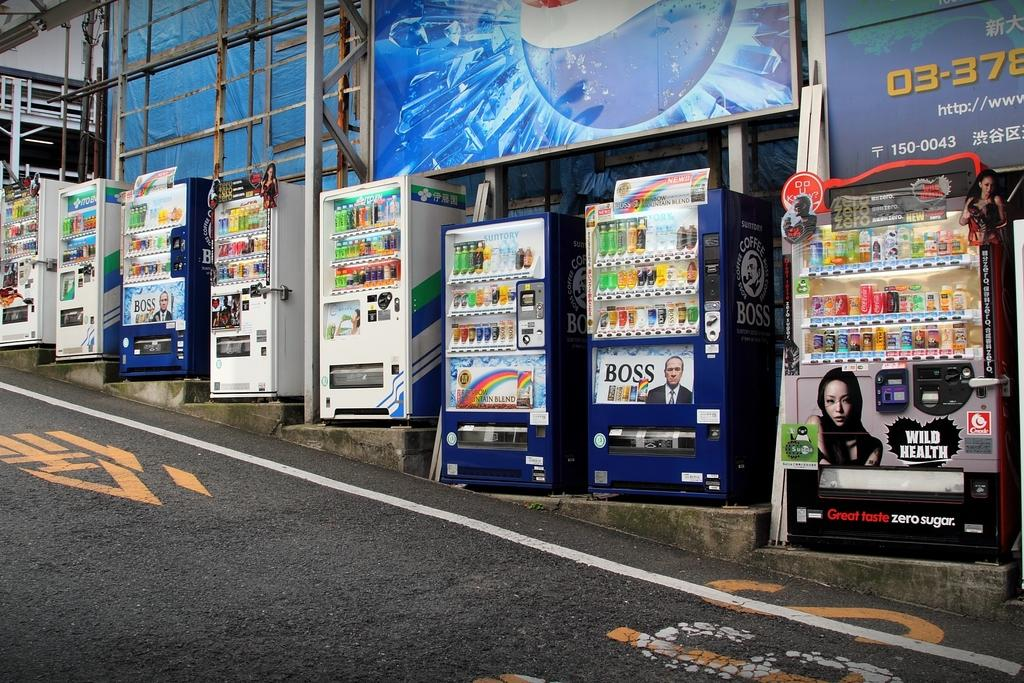<image>
Give a short and clear explanation of the subsequent image. A Wild Heath vending machine sits on the side of a street. 